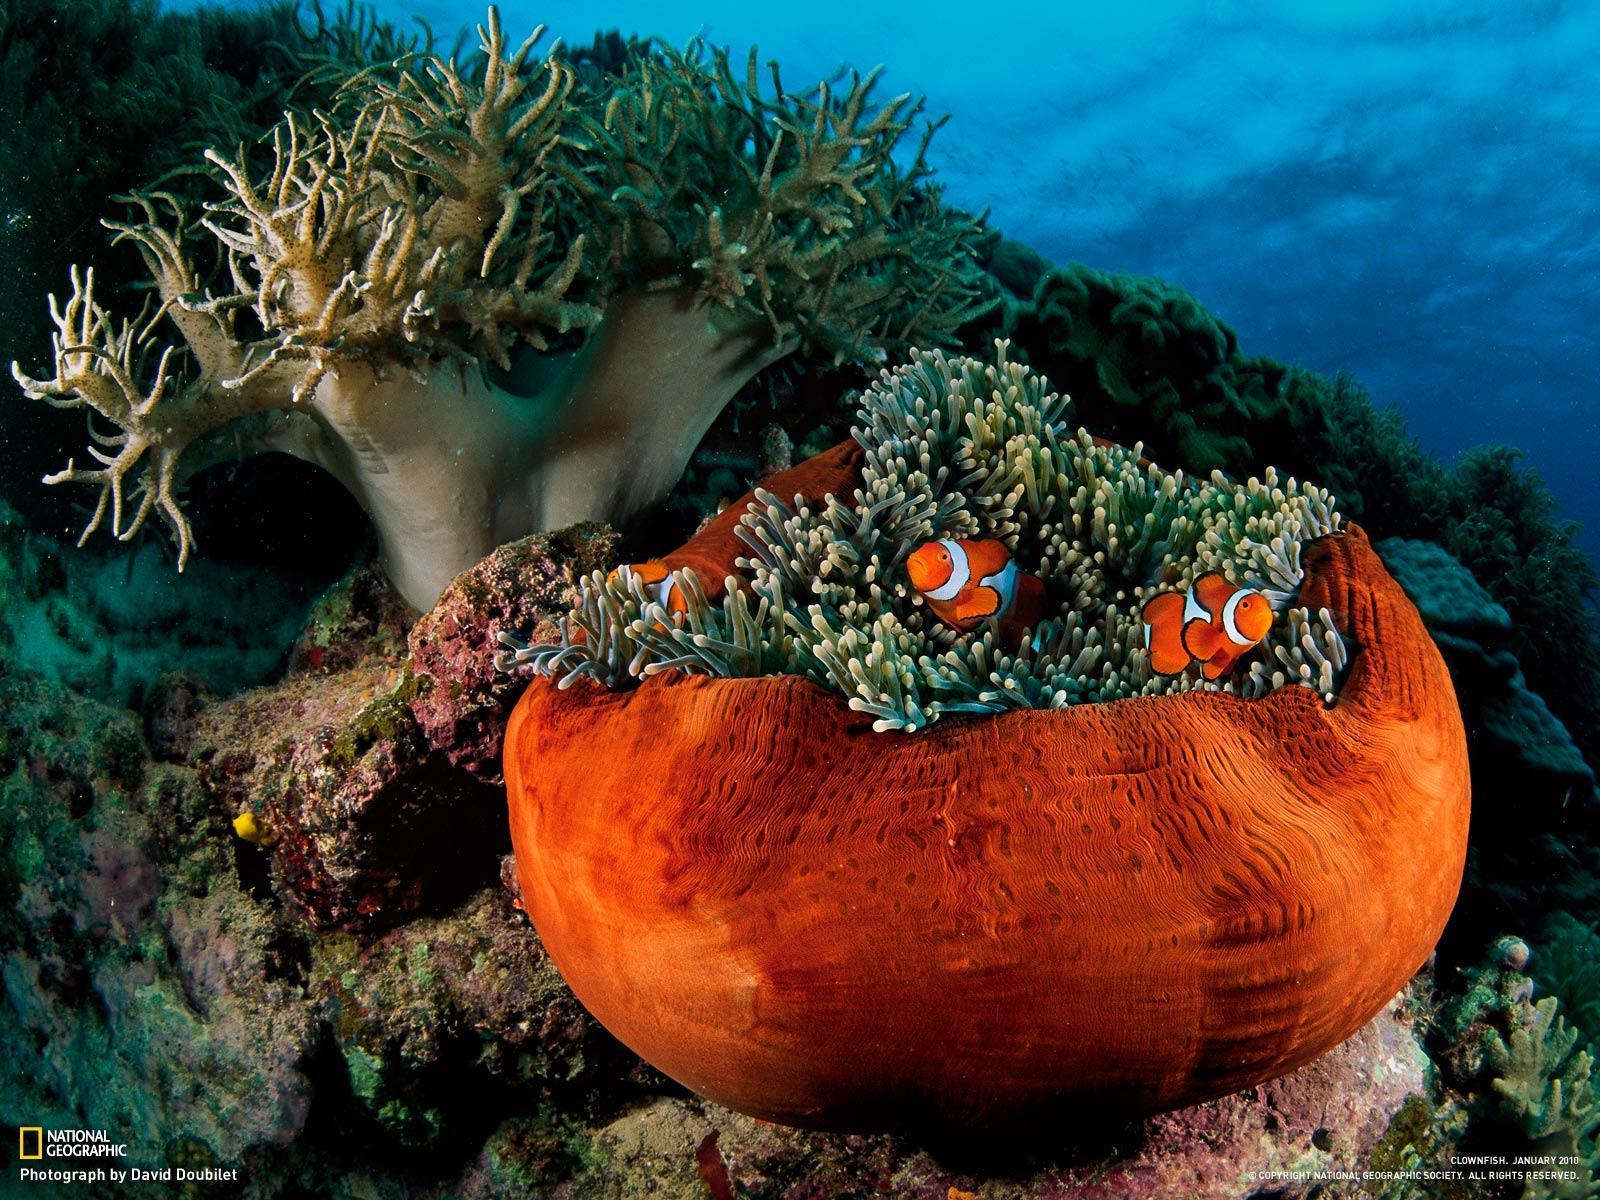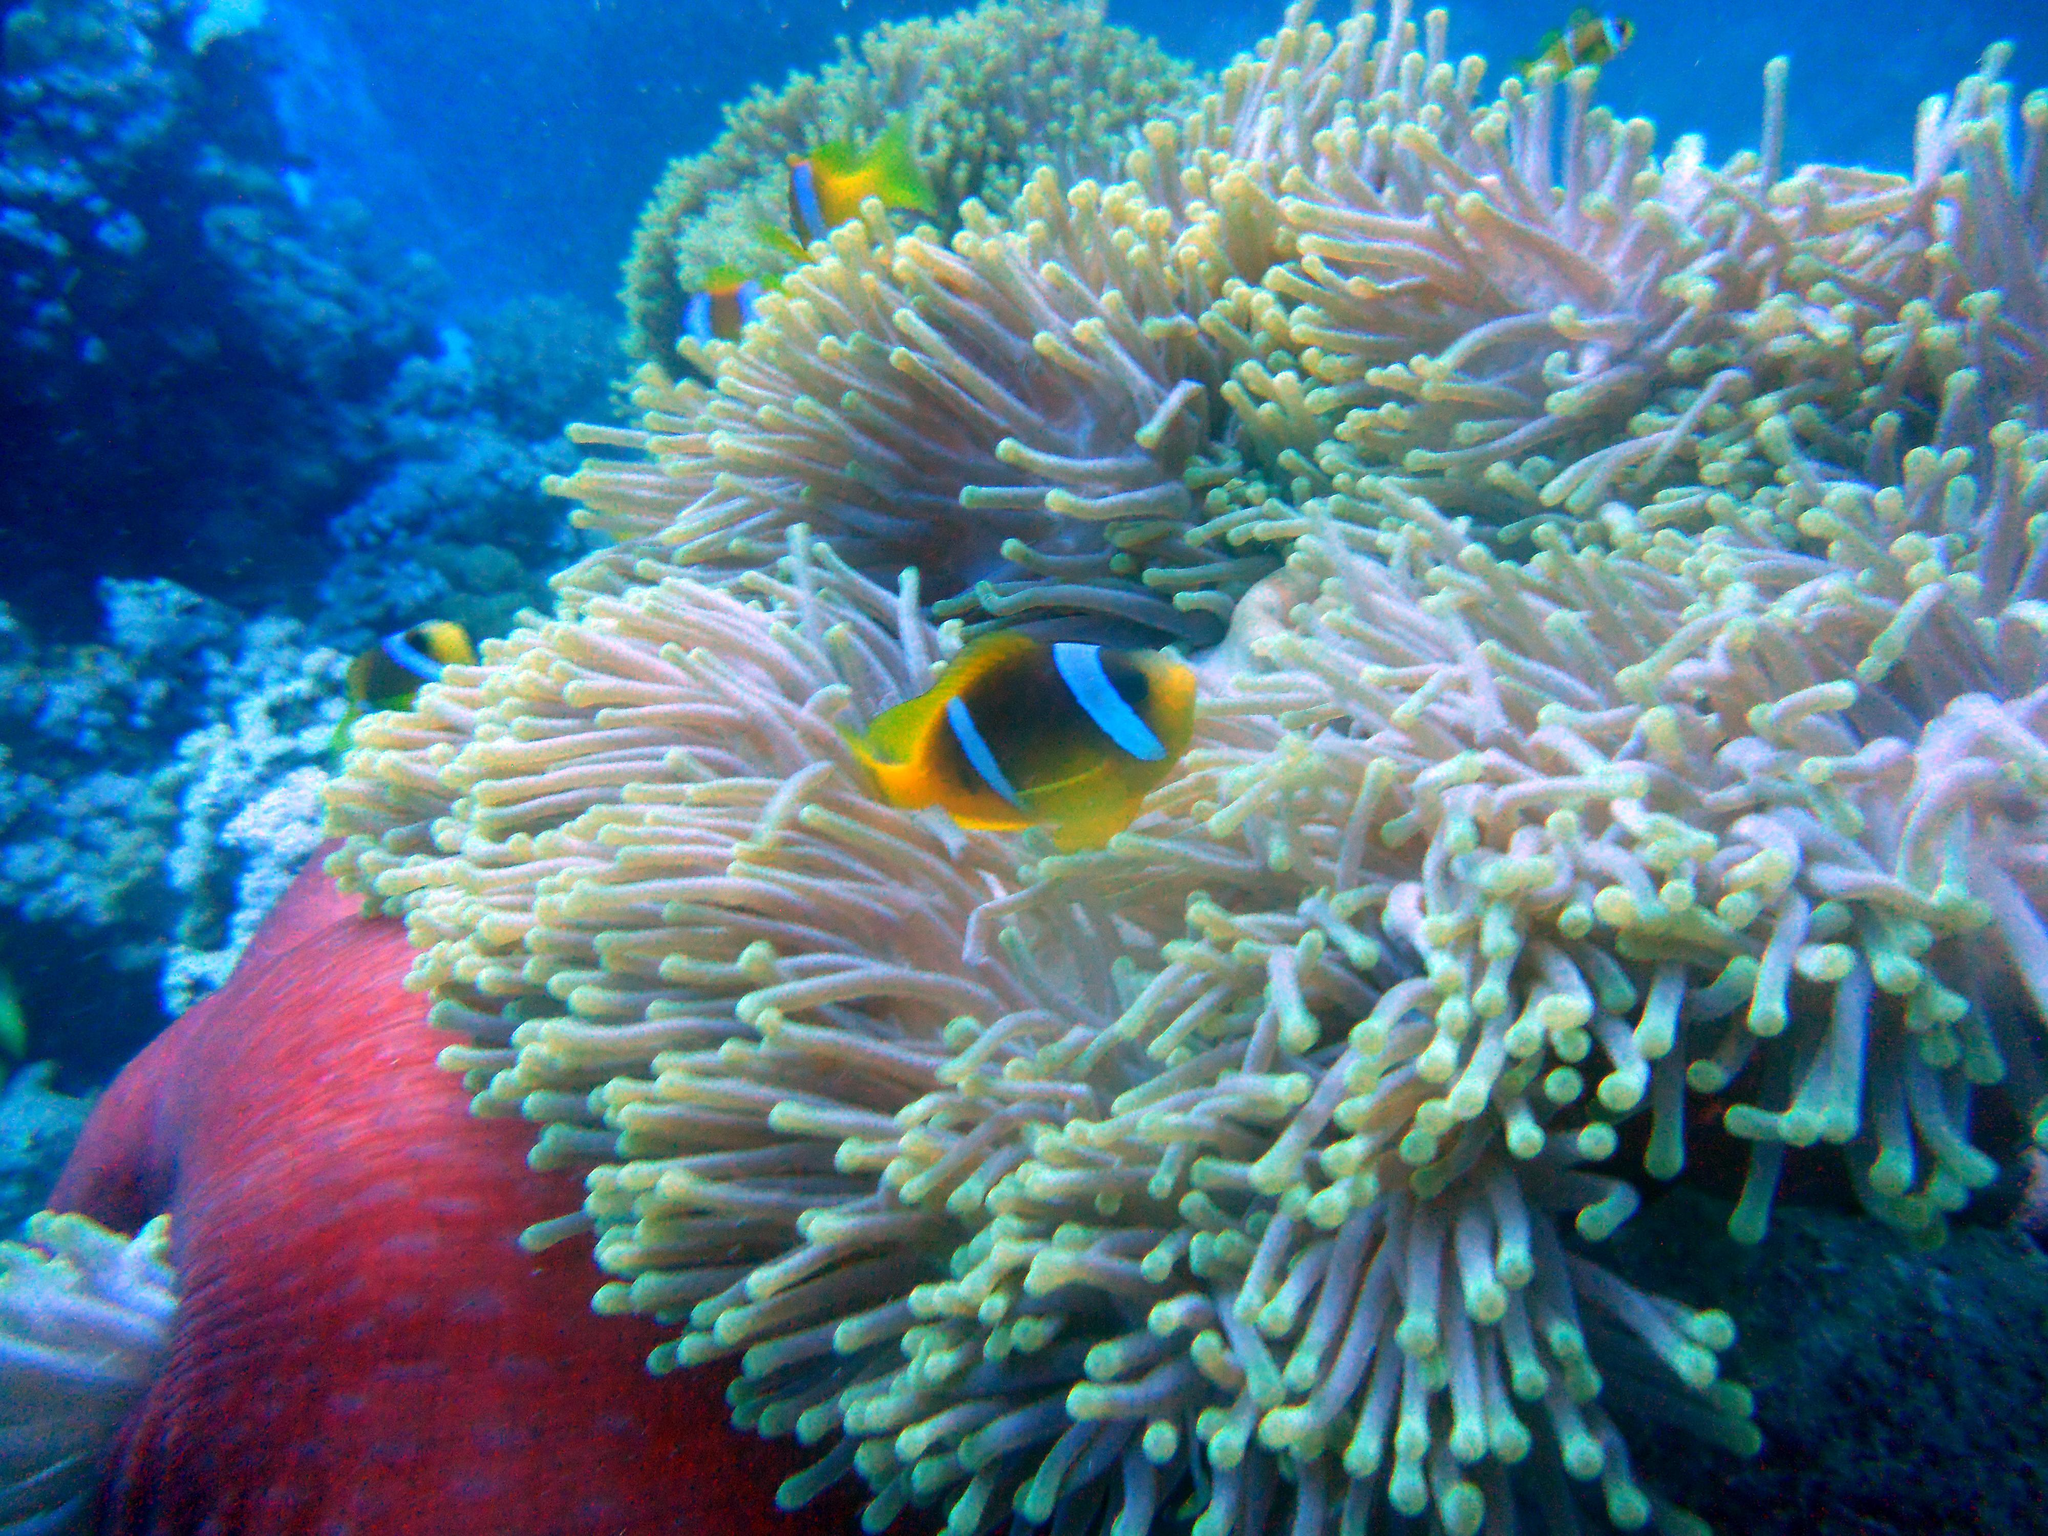The first image is the image on the left, the second image is the image on the right. Examine the images to the left and right. Is the description "A bright yellow fish is swimming in the water in the image on the left." accurate? Answer yes or no. No. 